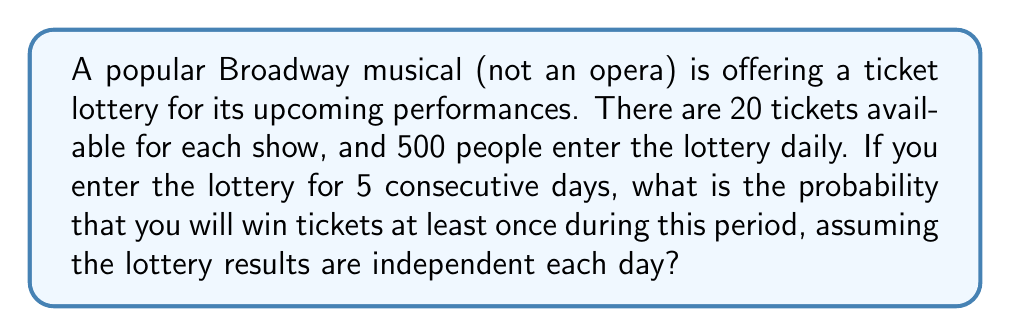Can you answer this question? Let's approach this step-by-step:

1) First, let's calculate the probability of winning on a single day:
   Probability of winning = $\frac{\text{Number of tickets}}{\text{Number of entries}} = \frac{20}{500} = \frac{1}{25} = 0.04$

2) The probability of not winning on a single day is:
   $1 - 0.04 = 0.96$

3) Now, we need to find the probability of not winning for all 5 days:
   $(0.96)^5 \approx 0.8154$

4) The probability of winning at least once is the opposite of not winning at all:
   $1 - (0.96)^5 \approx 1 - 0.8154 = 0.1846$

5) To express this as a percentage:
   $0.1846 \times 100\% \approx 18.46\%$

Therefore, the probability of winning tickets at least once in 5 days is approximately 18.46%.
Answer: $18.46\%$ 